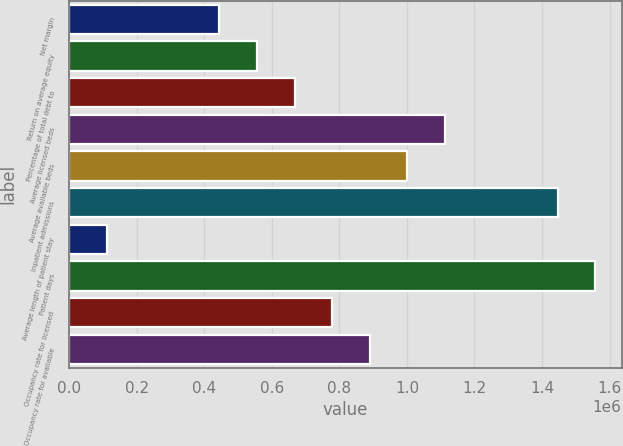Convert chart. <chart><loc_0><loc_0><loc_500><loc_500><bar_chart><fcel>Net margin<fcel>Return on average equity<fcel>Percentage of total debt to<fcel>Average licensed beds<fcel>Average available beds<fcel>Inpatient admissions<fcel>Average length of patient stay<fcel>Patient days<fcel>Occupancy rate for licensed<fcel>Occupancy rate for available<nl><fcel>445017<fcel>556271<fcel>667525<fcel>1.11254e+06<fcel>1.00129e+06<fcel>1.4463e+06<fcel>111254<fcel>1.55756e+06<fcel>778779<fcel>890033<nl></chart> 